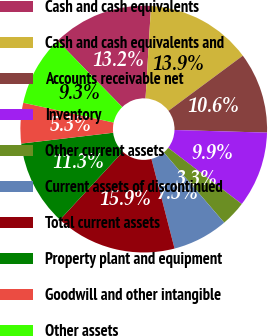Convert chart. <chart><loc_0><loc_0><loc_500><loc_500><pie_chart><fcel>Cash and cash equivalents<fcel>Cash and cash equivalents and<fcel>Accounts receivable net<fcel>Inventory<fcel>Other current assets<fcel>Current assets of discontinued<fcel>Total current assets<fcel>Property plant and equipment<fcel>Goodwill and other intangible<fcel>Other assets<nl><fcel>13.24%<fcel>13.91%<fcel>10.6%<fcel>9.93%<fcel>3.31%<fcel>7.29%<fcel>15.89%<fcel>11.26%<fcel>5.3%<fcel>9.27%<nl></chart> 